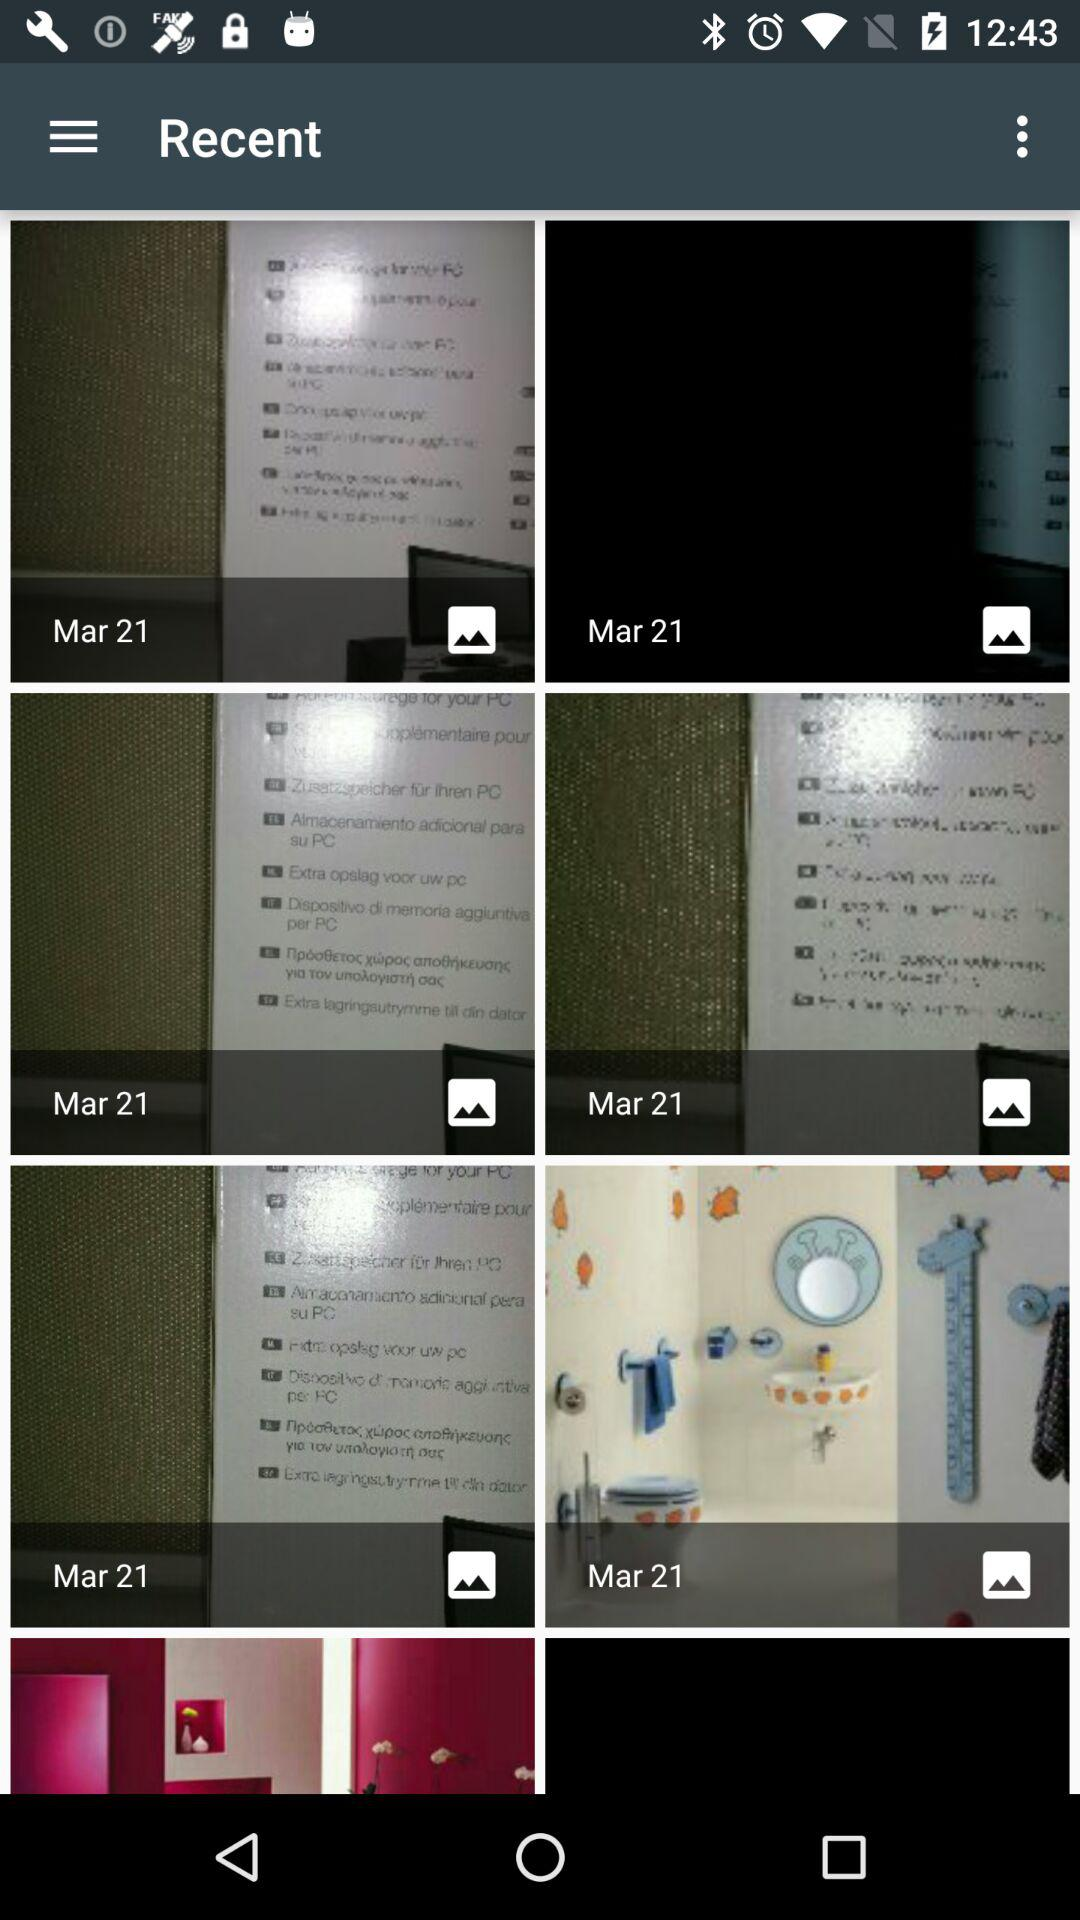What is the mentioned date? The mentioned date is March 21. 